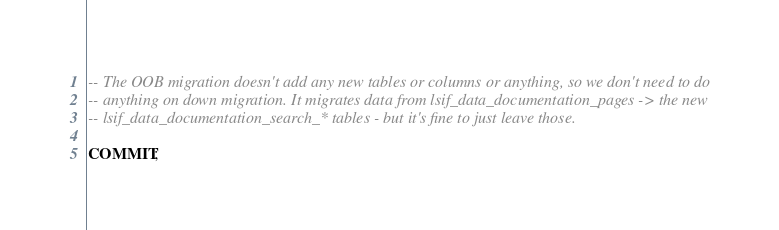Convert code to text. <code><loc_0><loc_0><loc_500><loc_500><_SQL_>-- The OOB migration doesn't add any new tables or columns or anything, so we don't need to do
-- anything on down migration. It migrates data from lsif_data_documentation_pages -> the new
-- lsif_data_documentation_search_* tables - but it's fine to just leave those.

COMMIT;
</code> 